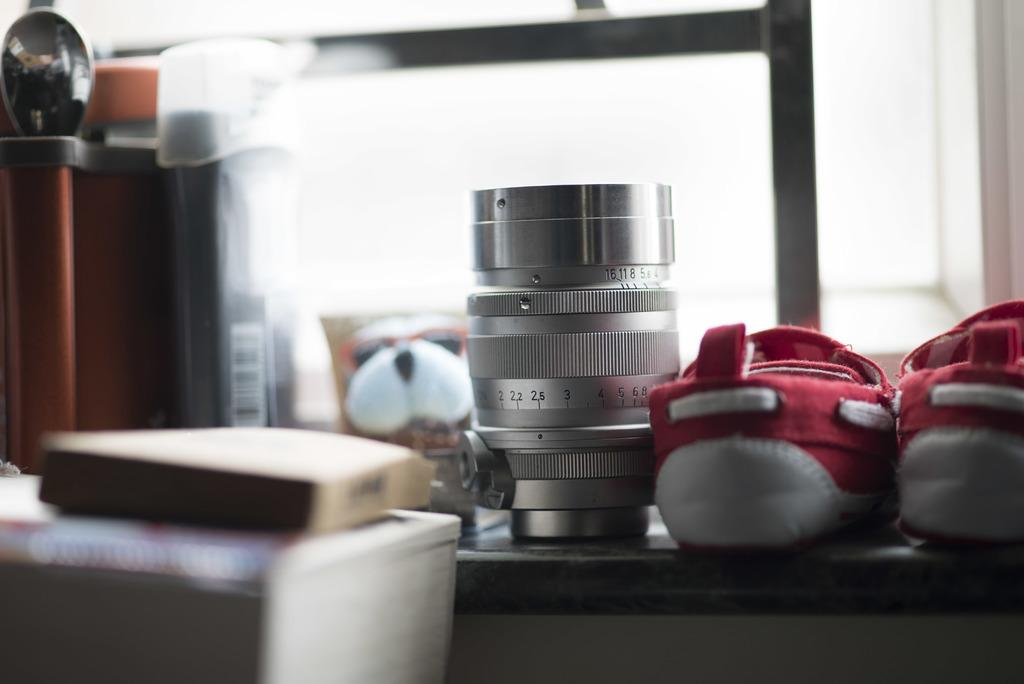What is the main subject of the image? The main subject of the image is a camera lens. What other objects can be seen in the image? There are shoes on a desk in the image. Where was the image likely taken? The image appears to be taken in a room. How many cherries are on the dog's collar in the image? There is no dog or cherries present in the image; it only features a camera lens and shoes on a desk. 